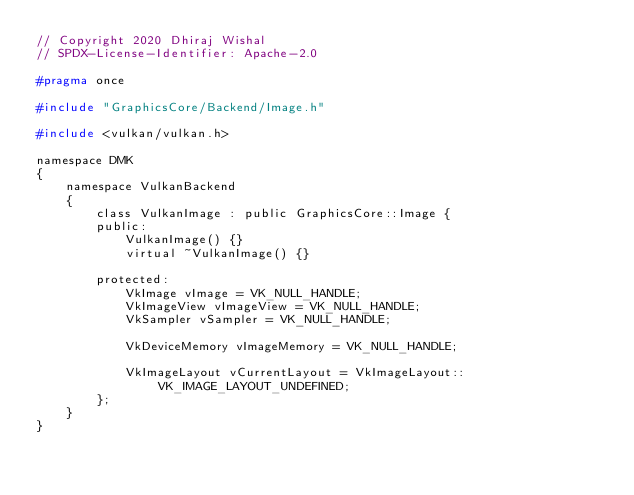Convert code to text. <code><loc_0><loc_0><loc_500><loc_500><_C_>// Copyright 2020 Dhiraj Wishal
// SPDX-License-Identifier: Apache-2.0

#pragma once

#include "GraphicsCore/Backend/Image.h"

#include <vulkan/vulkan.h>

namespace DMK
{
	namespace VulkanBackend
	{
		class VulkanImage : public GraphicsCore::Image {
		public:
			VulkanImage() {}
			virtual ~VulkanImage() {}

		protected:
			VkImage vImage = VK_NULL_HANDLE;
			VkImageView vImageView = VK_NULL_HANDLE;
			VkSampler vSampler = VK_NULL_HANDLE;

			VkDeviceMemory vImageMemory = VK_NULL_HANDLE;

			VkImageLayout vCurrentLayout = VkImageLayout::VK_IMAGE_LAYOUT_UNDEFINED;
		};
	}
}</code> 